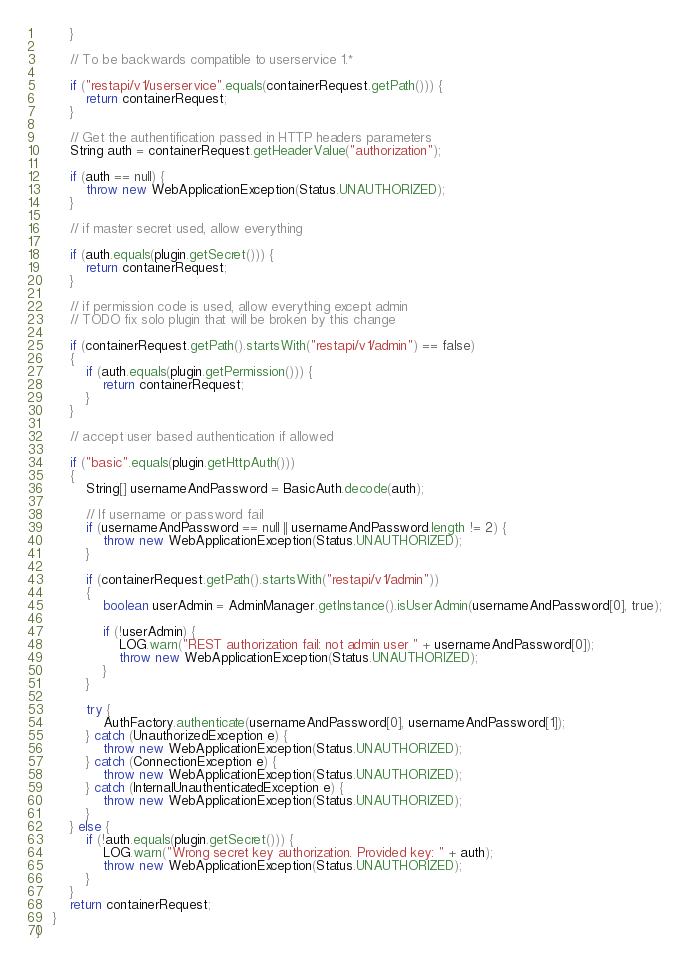<code> <loc_0><loc_0><loc_500><loc_500><_Java_>        }

        // To be backwards compatible to userservice 1.*

        if ("restapi/v1/userservice".equals(containerRequest.getPath())) {
            return containerRequest;
        }

        // Get the authentification passed in HTTP headers parameters
        String auth = containerRequest.getHeaderValue("authorization");

        if (auth == null) {
            throw new WebApplicationException(Status.UNAUTHORIZED);
        }

        // if master secret used, allow everything

        if (auth.equals(plugin.getSecret())) {
            return containerRequest;
        }

        // if permission code is used, allow everything except admin
        // TODO fix solo plugin that will be broken by this change

        if (containerRequest.getPath().startsWith("restapi/v1/admin") == false)
        {
            if (auth.equals(plugin.getPermission())) {
                return containerRequest;
            }
        }

        // accept user based authentication if allowed

        if ("basic".equals(plugin.getHttpAuth()))
        {
            String[] usernameAndPassword = BasicAuth.decode(auth);

            // If username or password fail
            if (usernameAndPassword == null || usernameAndPassword.length != 2) {
                throw new WebApplicationException(Status.UNAUTHORIZED);
            }

            if (containerRequest.getPath().startsWith("restapi/v1/admin"))
            {
                boolean userAdmin = AdminManager.getInstance().isUserAdmin(usernameAndPassword[0], true);

                if (!userAdmin) {
                    LOG.warn("REST authorization fail: not admin user " + usernameAndPassword[0]);
                    throw new WebApplicationException(Status.UNAUTHORIZED);
                }
            }

            try {
                AuthFactory.authenticate(usernameAndPassword[0], usernameAndPassword[1]);
            } catch (UnauthorizedException e) {
                throw new WebApplicationException(Status.UNAUTHORIZED);
            } catch (ConnectionException e) {
                throw new WebApplicationException(Status.UNAUTHORIZED);
            } catch (InternalUnauthenticatedException e) {
                throw new WebApplicationException(Status.UNAUTHORIZED);
            }
        } else {
            if (!auth.equals(plugin.getSecret())) {
                LOG.warn("Wrong secret key authorization. Provided key: " + auth);
                throw new WebApplicationException(Status.UNAUTHORIZED);
            }
        }
        return containerRequest;
    }
}
</code> 